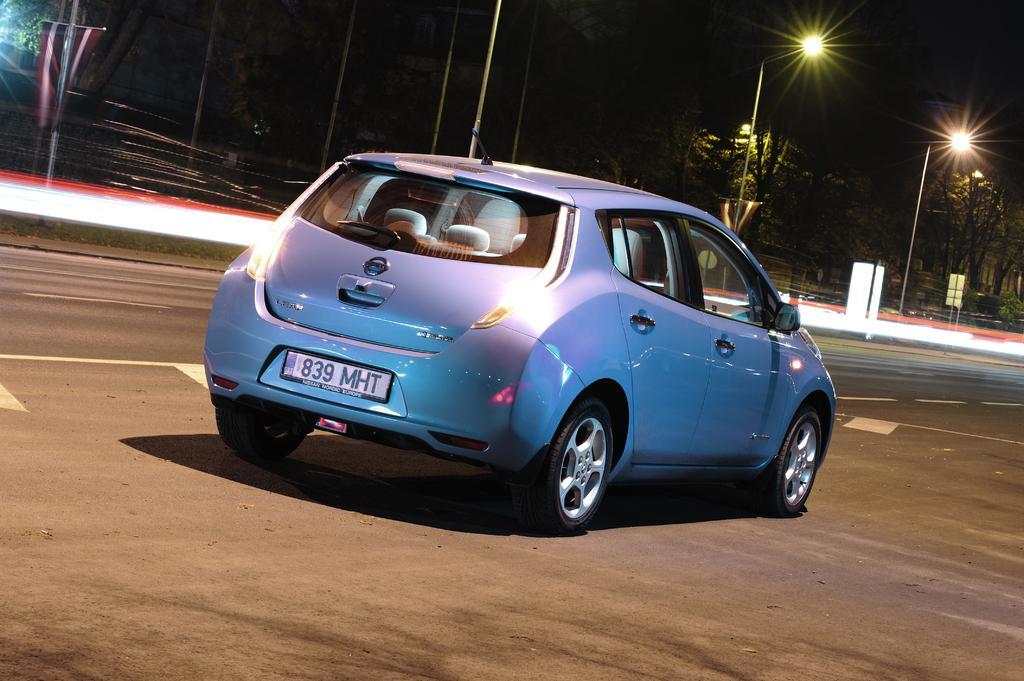Describe this image in one or two sentences. In the picture I can see a car on the road. In the background I can see a fence, trees, street lights, the sky and some other objects. 